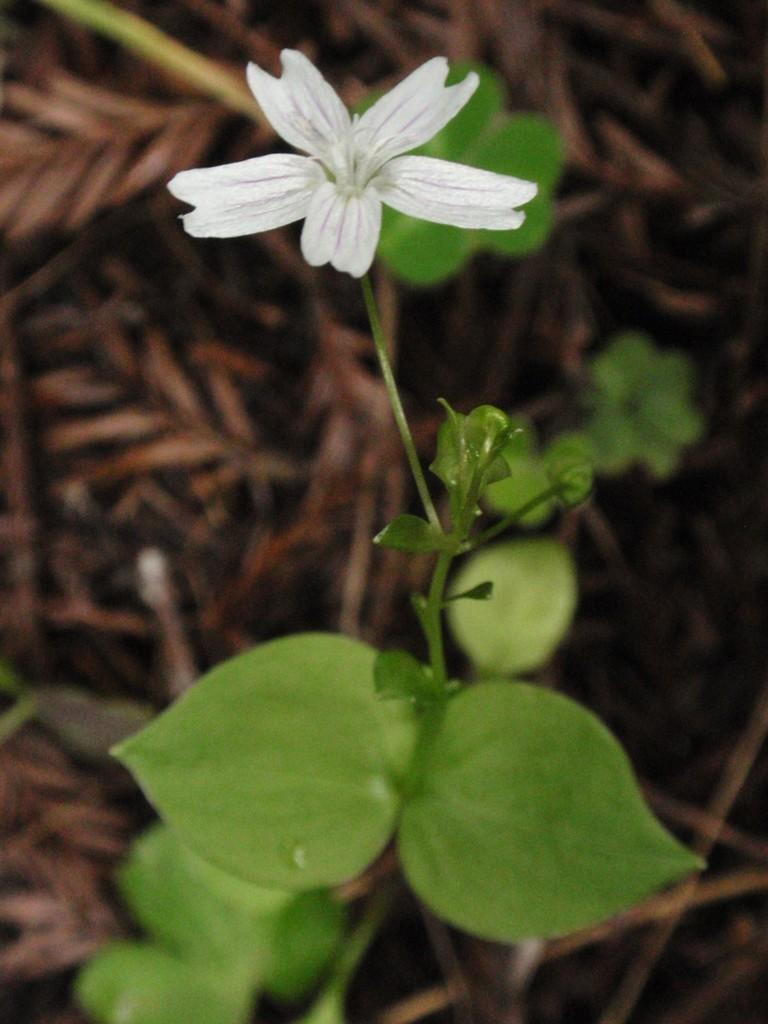What type of flower is present in the image? There is a white color flower in the image. Can you describe the plant in the image? The image contains a plant, but no specific details about the plant are provided. What type of good-bye message is written on the flower in the image? There is no good-bye message present on the flower in the image. 